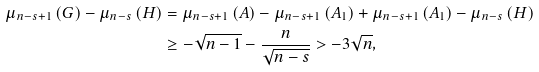<formula> <loc_0><loc_0><loc_500><loc_500>\mu _ { n - s + 1 } \left ( G \right ) - \mu _ { n - s } \left ( H \right ) & = \mu _ { n - s + 1 } \left ( A \right ) - \mu _ { n - s + 1 } \left ( A _ { 1 } \right ) + \mu _ { n - s + 1 } \left ( A _ { 1 } \right ) - \mu _ { n - s } \left ( H \right ) \\ & \geq - \sqrt { n - 1 } - \frac { n } { \sqrt { n - s } } > - 3 \sqrt { n } ,</formula> 